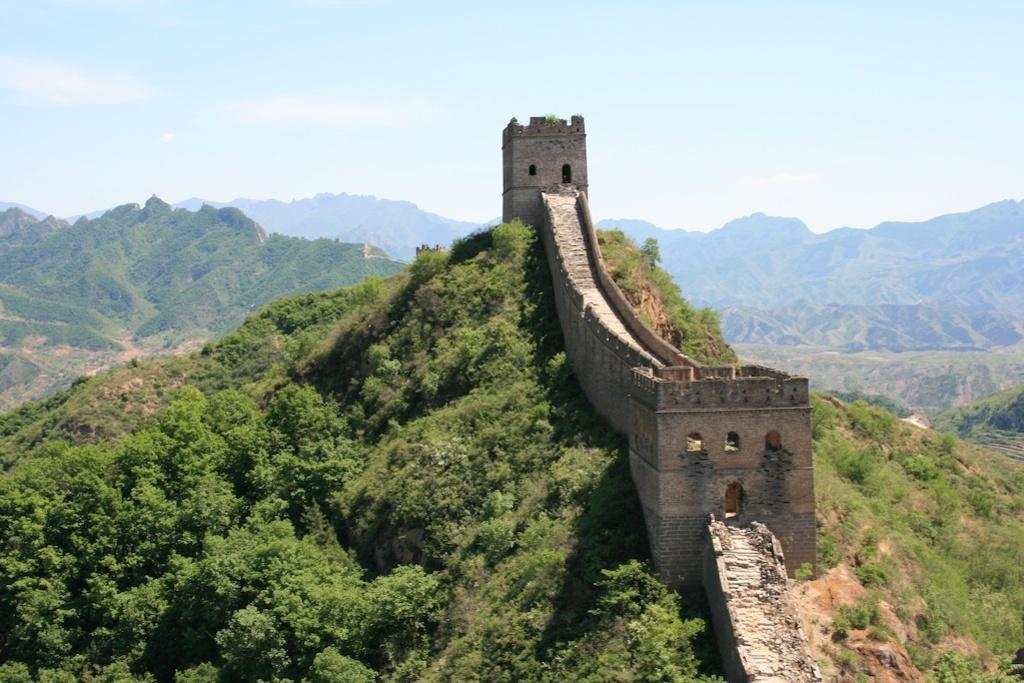Describe this image in one or two sentences. In this image we can see the great wall of china, trees, mountains and in the background we can see the sky. 